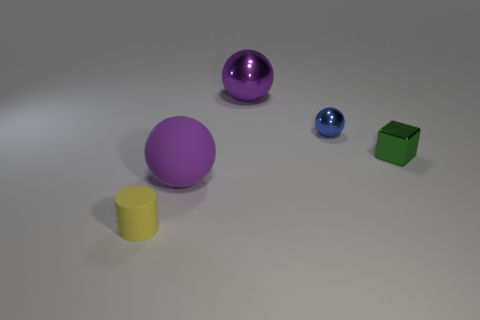Subtract all tiny spheres. How many spheres are left? 2 Subtract 0 gray balls. How many objects are left? 5 Subtract all blocks. How many objects are left? 4 Subtract 2 spheres. How many spheres are left? 1 Subtract all blue balls. Subtract all green cylinders. How many balls are left? 2 Subtract all red cylinders. How many blue balls are left? 1 Subtract all green objects. Subtract all big spheres. How many objects are left? 2 Add 5 rubber spheres. How many rubber spheres are left? 6 Add 5 purple metallic things. How many purple metallic things exist? 6 Add 2 red metallic things. How many objects exist? 7 